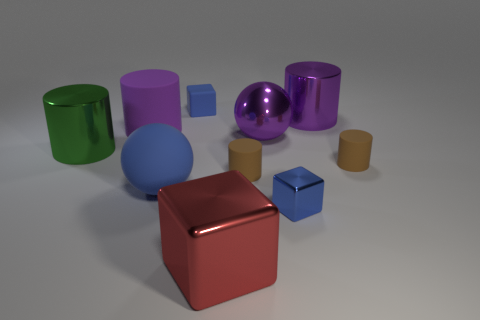Subtract 1 cylinders. How many cylinders are left? 4 Subtract all green cylinders. How many cylinders are left? 4 Subtract all big green cylinders. How many cylinders are left? 4 Subtract all cyan cylinders. Subtract all gray spheres. How many cylinders are left? 5 Subtract all blocks. How many objects are left? 7 Add 7 large rubber things. How many large rubber things exist? 9 Subtract 0 green cubes. How many objects are left? 10 Subtract all tiny cylinders. Subtract all large green shiny cylinders. How many objects are left? 7 Add 8 large purple rubber objects. How many large purple rubber objects are left? 9 